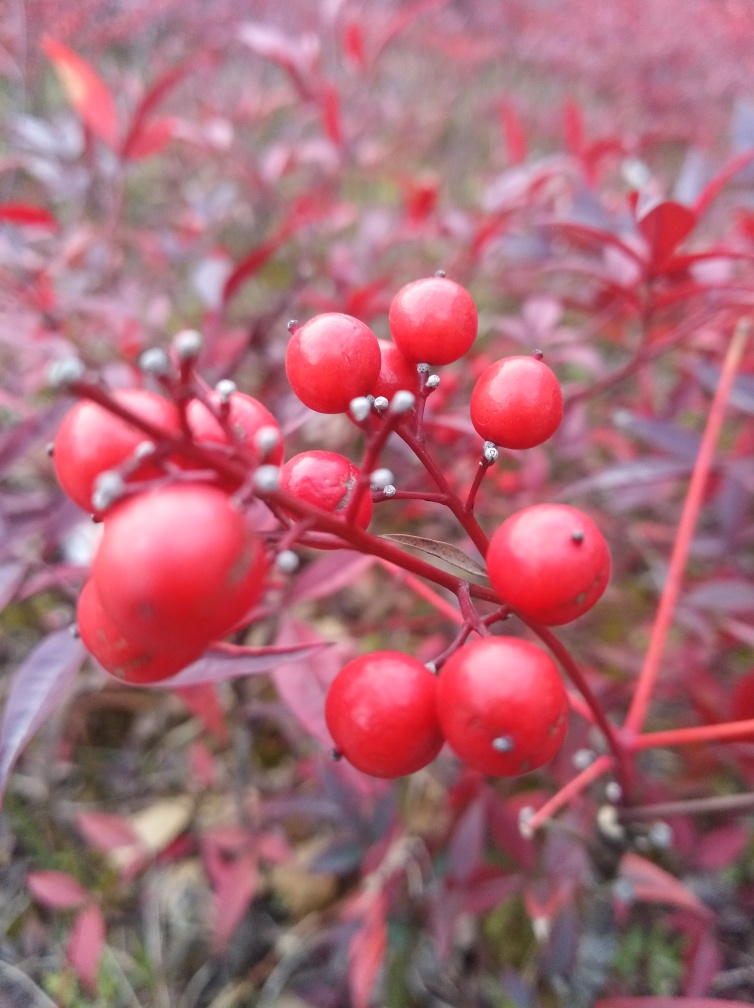Is there any noise in the background of the photo? The photo appears to be taken in a quiet natural setting without any visible elements that would indicate noise, such as people or machinery. However, since this is an image, I cannot confirm the actual level of noise at the time it was taken. 